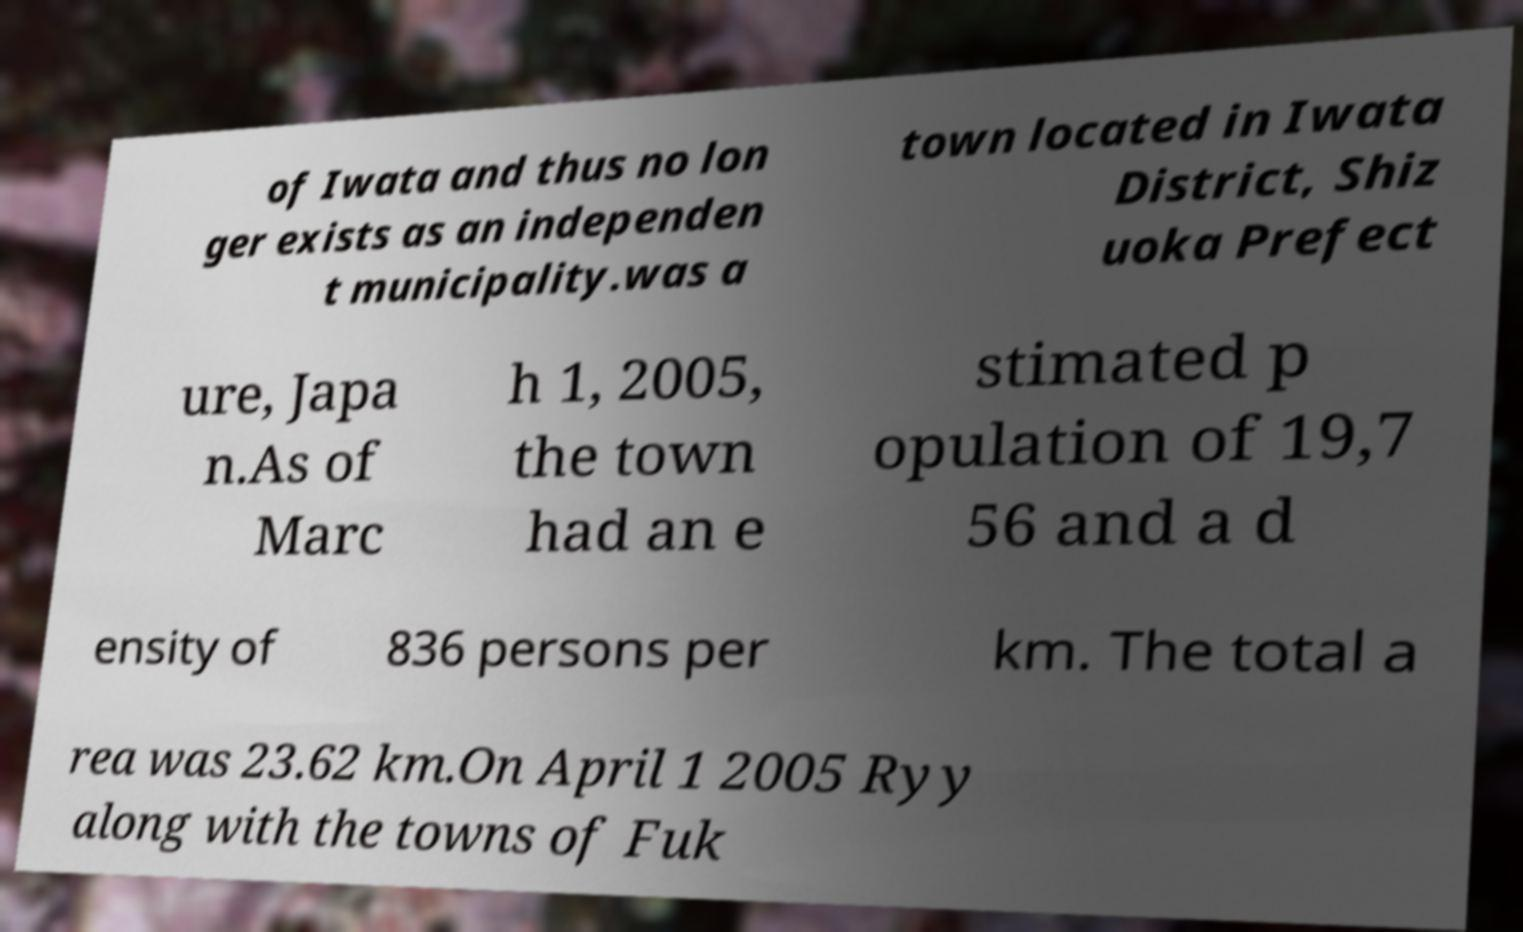Please identify and transcribe the text found in this image. of Iwata and thus no lon ger exists as an independen t municipality.was a town located in Iwata District, Shiz uoka Prefect ure, Japa n.As of Marc h 1, 2005, the town had an e stimated p opulation of 19,7 56 and a d ensity of 836 persons per km. The total a rea was 23.62 km.On April 1 2005 Ryy along with the towns of Fuk 